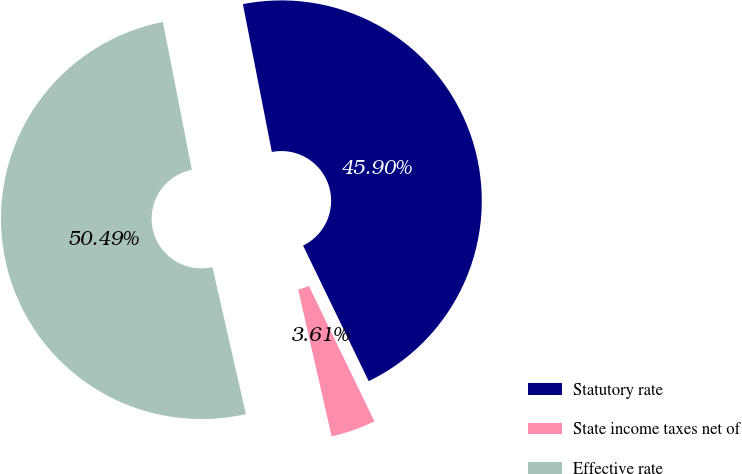Convert chart. <chart><loc_0><loc_0><loc_500><loc_500><pie_chart><fcel>Statutory rate<fcel>State income taxes net of<fcel>Effective rate<nl><fcel>45.9%<fcel>3.61%<fcel>50.49%<nl></chart> 